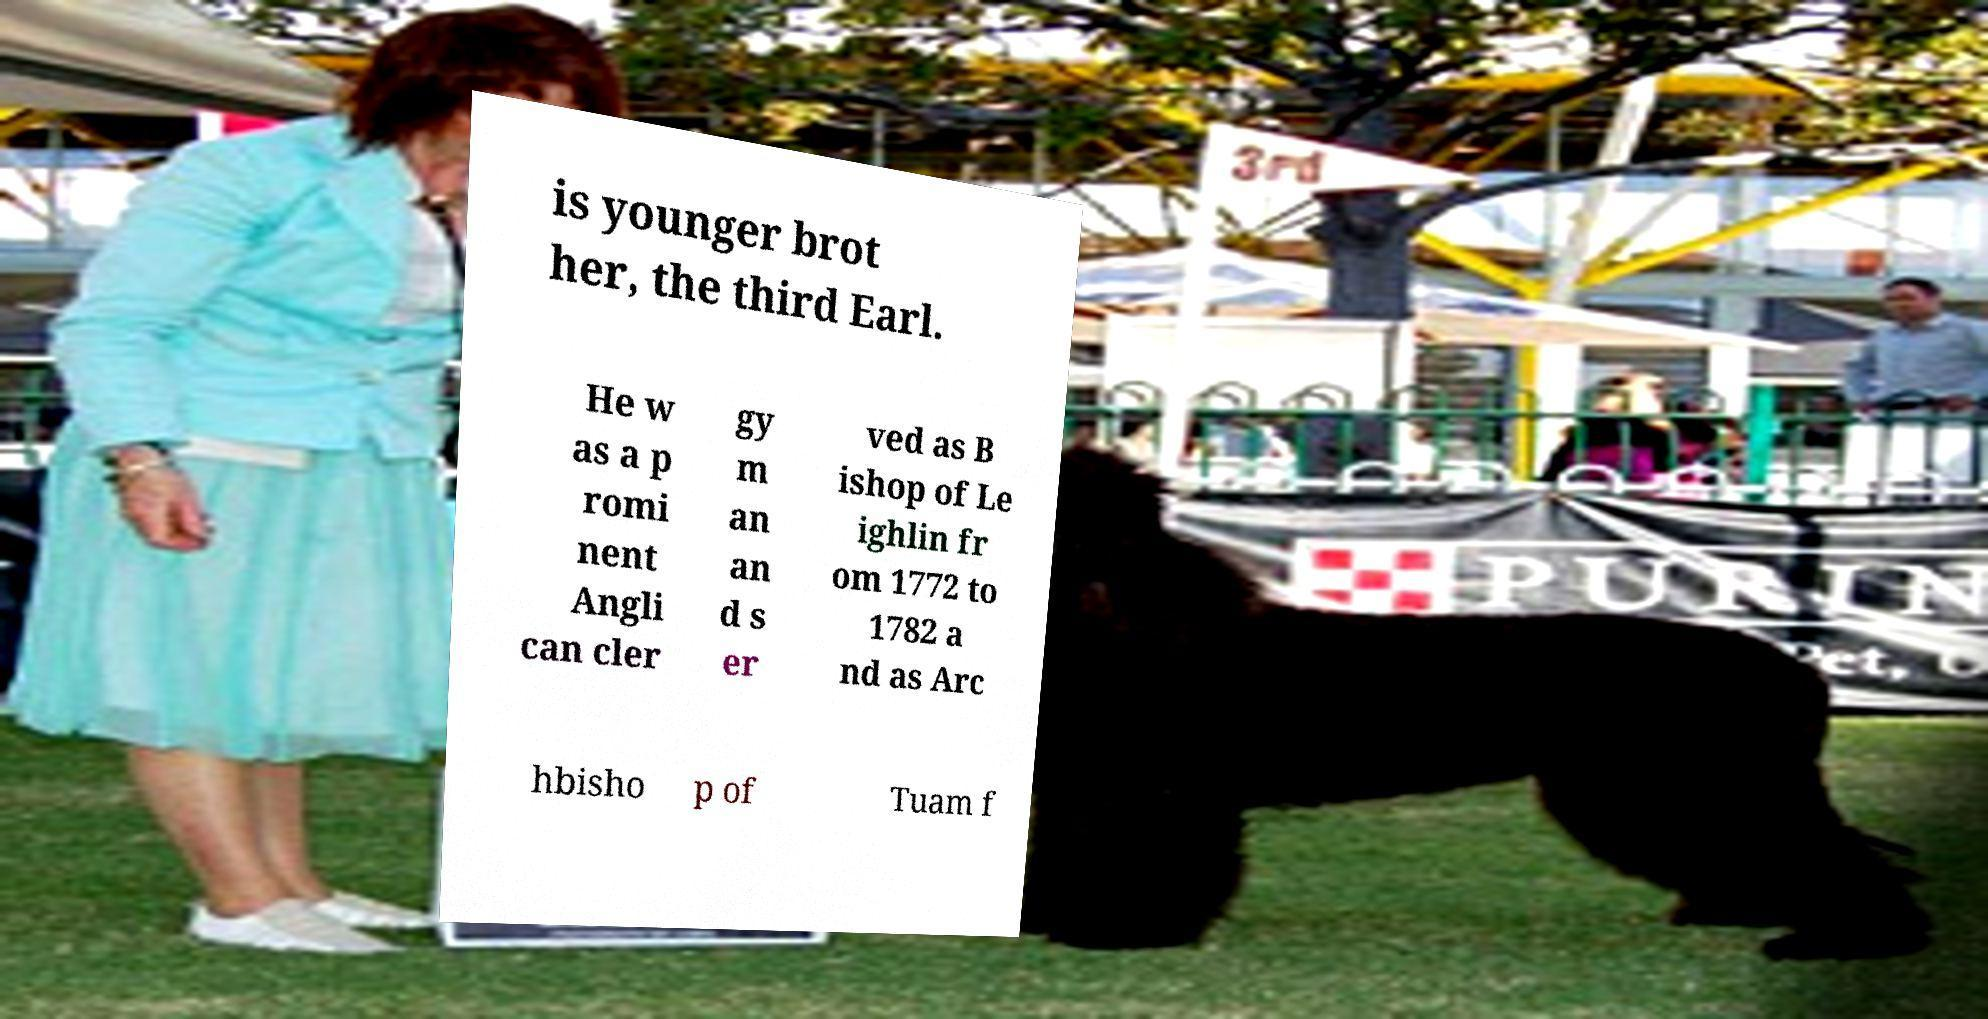There's text embedded in this image that I need extracted. Can you transcribe it verbatim? is younger brot her, the third Earl. He w as a p romi nent Angli can cler gy m an an d s er ved as B ishop of Le ighlin fr om 1772 to 1782 a nd as Arc hbisho p of Tuam f 